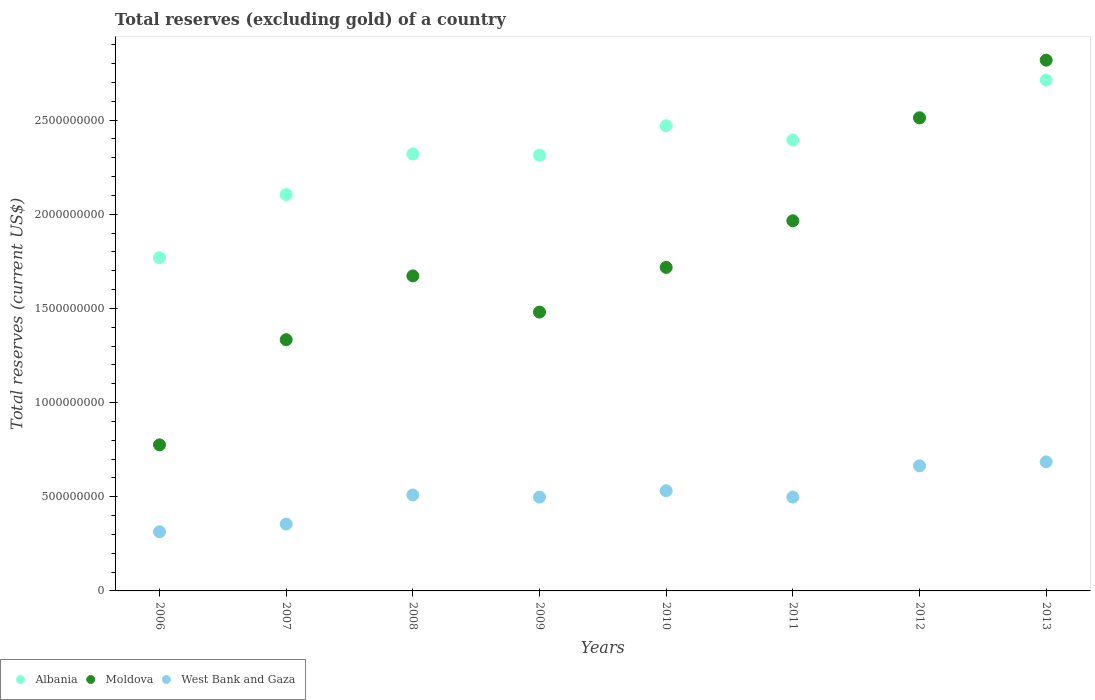What is the total reserves (excluding gold) in Albania in 2008?
Provide a short and direct response. 2.32e+09. Across all years, what is the maximum total reserves (excluding gold) in Moldova?
Give a very brief answer. 2.82e+09. Across all years, what is the minimum total reserves (excluding gold) in West Bank and Gaza?
Provide a succinct answer. 3.14e+08. In which year was the total reserves (excluding gold) in Moldova minimum?
Provide a succinct answer. 2006. What is the total total reserves (excluding gold) in Albania in the graph?
Give a very brief answer. 1.86e+1. What is the difference between the total reserves (excluding gold) in West Bank and Gaza in 2007 and that in 2012?
Provide a short and direct response. -3.09e+08. What is the difference between the total reserves (excluding gold) in Albania in 2006 and the total reserves (excluding gold) in West Bank and Gaza in 2007?
Your answer should be very brief. 1.41e+09. What is the average total reserves (excluding gold) in Moldova per year?
Give a very brief answer. 1.78e+09. In the year 2013, what is the difference between the total reserves (excluding gold) in Albania and total reserves (excluding gold) in Moldova?
Keep it short and to the point. -1.05e+08. What is the ratio of the total reserves (excluding gold) in Albania in 2010 to that in 2013?
Your answer should be compact. 0.91. What is the difference between the highest and the second highest total reserves (excluding gold) in West Bank and Gaza?
Keep it short and to the point. 2.12e+07. What is the difference between the highest and the lowest total reserves (excluding gold) in Albania?
Keep it short and to the point. 9.44e+08. In how many years, is the total reserves (excluding gold) in Moldova greater than the average total reserves (excluding gold) in Moldova taken over all years?
Keep it short and to the point. 3. Is it the case that in every year, the sum of the total reserves (excluding gold) in Moldova and total reserves (excluding gold) in West Bank and Gaza  is greater than the total reserves (excluding gold) in Albania?
Your answer should be compact. No. Does the total reserves (excluding gold) in West Bank and Gaza monotonically increase over the years?
Your response must be concise. No. Is the total reserves (excluding gold) in Moldova strictly greater than the total reserves (excluding gold) in Albania over the years?
Keep it short and to the point. No. How many dotlines are there?
Provide a succinct answer. 3. How many years are there in the graph?
Offer a terse response. 8. What is the difference between two consecutive major ticks on the Y-axis?
Give a very brief answer. 5.00e+08. Are the values on the major ticks of Y-axis written in scientific E-notation?
Offer a terse response. No. Does the graph contain any zero values?
Your response must be concise. No. Where does the legend appear in the graph?
Offer a very short reply. Bottom left. How are the legend labels stacked?
Provide a succinct answer. Horizontal. What is the title of the graph?
Provide a succinct answer. Total reserves (excluding gold) of a country. What is the label or title of the Y-axis?
Ensure brevity in your answer.  Total reserves (current US$). What is the Total reserves (current US$) of Albania in 2006?
Give a very brief answer. 1.77e+09. What is the Total reserves (current US$) of Moldova in 2006?
Provide a succinct answer. 7.75e+08. What is the Total reserves (current US$) in West Bank and Gaza in 2006?
Provide a succinct answer. 3.14e+08. What is the Total reserves (current US$) in Albania in 2007?
Your answer should be very brief. 2.10e+09. What is the Total reserves (current US$) of Moldova in 2007?
Your answer should be very brief. 1.33e+09. What is the Total reserves (current US$) in West Bank and Gaza in 2007?
Provide a short and direct response. 3.55e+08. What is the Total reserves (current US$) in Albania in 2008?
Offer a very short reply. 2.32e+09. What is the Total reserves (current US$) of Moldova in 2008?
Give a very brief answer. 1.67e+09. What is the Total reserves (current US$) of West Bank and Gaza in 2008?
Keep it short and to the point. 5.10e+08. What is the Total reserves (current US$) of Albania in 2009?
Your answer should be compact. 2.31e+09. What is the Total reserves (current US$) of Moldova in 2009?
Give a very brief answer. 1.48e+09. What is the Total reserves (current US$) in West Bank and Gaza in 2009?
Your answer should be compact. 4.98e+08. What is the Total reserves (current US$) of Albania in 2010?
Ensure brevity in your answer.  2.47e+09. What is the Total reserves (current US$) in Moldova in 2010?
Your answer should be compact. 1.72e+09. What is the Total reserves (current US$) in West Bank and Gaza in 2010?
Ensure brevity in your answer.  5.32e+08. What is the Total reserves (current US$) in Albania in 2011?
Keep it short and to the point. 2.39e+09. What is the Total reserves (current US$) in Moldova in 2011?
Make the answer very short. 1.96e+09. What is the Total reserves (current US$) of West Bank and Gaza in 2011?
Ensure brevity in your answer.  4.98e+08. What is the Total reserves (current US$) of Albania in 2012?
Your answer should be very brief. 2.52e+09. What is the Total reserves (current US$) of Moldova in 2012?
Keep it short and to the point. 2.51e+09. What is the Total reserves (current US$) of West Bank and Gaza in 2012?
Offer a terse response. 6.64e+08. What is the Total reserves (current US$) of Albania in 2013?
Provide a succinct answer. 2.71e+09. What is the Total reserves (current US$) in Moldova in 2013?
Your answer should be very brief. 2.82e+09. What is the Total reserves (current US$) in West Bank and Gaza in 2013?
Offer a very short reply. 6.85e+08. Across all years, what is the maximum Total reserves (current US$) of Albania?
Your answer should be compact. 2.71e+09. Across all years, what is the maximum Total reserves (current US$) of Moldova?
Offer a very short reply. 2.82e+09. Across all years, what is the maximum Total reserves (current US$) of West Bank and Gaza?
Your answer should be very brief. 6.85e+08. Across all years, what is the minimum Total reserves (current US$) of Albania?
Keep it short and to the point. 1.77e+09. Across all years, what is the minimum Total reserves (current US$) in Moldova?
Your answer should be very brief. 7.75e+08. Across all years, what is the minimum Total reserves (current US$) of West Bank and Gaza?
Provide a succinct answer. 3.14e+08. What is the total Total reserves (current US$) of Albania in the graph?
Provide a succinct answer. 1.86e+1. What is the total Total reserves (current US$) in Moldova in the graph?
Give a very brief answer. 1.43e+1. What is the total Total reserves (current US$) in West Bank and Gaza in the graph?
Provide a short and direct response. 4.06e+09. What is the difference between the Total reserves (current US$) in Albania in 2006 and that in 2007?
Provide a succinct answer. -3.35e+08. What is the difference between the Total reserves (current US$) of Moldova in 2006 and that in 2007?
Provide a succinct answer. -5.58e+08. What is the difference between the Total reserves (current US$) of West Bank and Gaza in 2006 and that in 2007?
Give a very brief answer. -4.07e+07. What is the difference between the Total reserves (current US$) of Albania in 2006 and that in 2008?
Keep it short and to the point. -5.51e+08. What is the difference between the Total reserves (current US$) of Moldova in 2006 and that in 2008?
Offer a very short reply. -8.97e+08. What is the difference between the Total reserves (current US$) in West Bank and Gaza in 2006 and that in 2008?
Your answer should be compact. -1.95e+08. What is the difference between the Total reserves (current US$) of Albania in 2006 and that in 2009?
Give a very brief answer. -5.45e+08. What is the difference between the Total reserves (current US$) in Moldova in 2006 and that in 2009?
Your answer should be compact. -7.05e+08. What is the difference between the Total reserves (current US$) in West Bank and Gaza in 2006 and that in 2009?
Keep it short and to the point. -1.84e+08. What is the difference between the Total reserves (current US$) in Albania in 2006 and that in 2010?
Give a very brief answer. -7.01e+08. What is the difference between the Total reserves (current US$) in Moldova in 2006 and that in 2010?
Offer a terse response. -9.42e+08. What is the difference between the Total reserves (current US$) of West Bank and Gaza in 2006 and that in 2010?
Offer a very short reply. -2.18e+08. What is the difference between the Total reserves (current US$) in Albania in 2006 and that in 2011?
Your answer should be compact. -6.25e+08. What is the difference between the Total reserves (current US$) in Moldova in 2006 and that in 2011?
Keep it short and to the point. -1.19e+09. What is the difference between the Total reserves (current US$) in West Bank and Gaza in 2006 and that in 2011?
Make the answer very short. -1.84e+08. What is the difference between the Total reserves (current US$) of Albania in 2006 and that in 2012?
Offer a terse response. -7.47e+08. What is the difference between the Total reserves (current US$) in Moldova in 2006 and that in 2012?
Ensure brevity in your answer.  -1.74e+09. What is the difference between the Total reserves (current US$) of West Bank and Gaza in 2006 and that in 2012?
Make the answer very short. -3.50e+08. What is the difference between the Total reserves (current US$) of Albania in 2006 and that in 2013?
Provide a succinct answer. -9.44e+08. What is the difference between the Total reserves (current US$) in Moldova in 2006 and that in 2013?
Offer a terse response. -2.04e+09. What is the difference between the Total reserves (current US$) of West Bank and Gaza in 2006 and that in 2013?
Keep it short and to the point. -3.71e+08. What is the difference between the Total reserves (current US$) in Albania in 2007 and that in 2008?
Keep it short and to the point. -2.16e+08. What is the difference between the Total reserves (current US$) of Moldova in 2007 and that in 2008?
Your answer should be very brief. -3.39e+08. What is the difference between the Total reserves (current US$) of West Bank and Gaza in 2007 and that in 2008?
Your answer should be very brief. -1.55e+08. What is the difference between the Total reserves (current US$) in Albania in 2007 and that in 2009?
Offer a terse response. -2.10e+08. What is the difference between the Total reserves (current US$) of Moldova in 2007 and that in 2009?
Your response must be concise. -1.47e+08. What is the difference between the Total reserves (current US$) in West Bank and Gaza in 2007 and that in 2009?
Your answer should be very brief. -1.43e+08. What is the difference between the Total reserves (current US$) in Albania in 2007 and that in 2010?
Give a very brief answer. -3.65e+08. What is the difference between the Total reserves (current US$) of Moldova in 2007 and that in 2010?
Provide a succinct answer. -3.84e+08. What is the difference between the Total reserves (current US$) of West Bank and Gaza in 2007 and that in 2010?
Keep it short and to the point. -1.77e+08. What is the difference between the Total reserves (current US$) of Albania in 2007 and that in 2011?
Your answer should be compact. -2.90e+08. What is the difference between the Total reserves (current US$) in Moldova in 2007 and that in 2011?
Offer a very short reply. -6.31e+08. What is the difference between the Total reserves (current US$) in West Bank and Gaza in 2007 and that in 2011?
Your answer should be compact. -1.43e+08. What is the difference between the Total reserves (current US$) of Albania in 2007 and that in 2012?
Your answer should be very brief. -4.11e+08. What is the difference between the Total reserves (current US$) of Moldova in 2007 and that in 2012?
Your response must be concise. -1.18e+09. What is the difference between the Total reserves (current US$) of West Bank and Gaza in 2007 and that in 2012?
Offer a terse response. -3.09e+08. What is the difference between the Total reserves (current US$) in Albania in 2007 and that in 2013?
Make the answer very short. -6.08e+08. What is the difference between the Total reserves (current US$) of Moldova in 2007 and that in 2013?
Your response must be concise. -1.48e+09. What is the difference between the Total reserves (current US$) in West Bank and Gaza in 2007 and that in 2013?
Give a very brief answer. -3.30e+08. What is the difference between the Total reserves (current US$) of Albania in 2008 and that in 2009?
Provide a succinct answer. 5.87e+06. What is the difference between the Total reserves (current US$) of Moldova in 2008 and that in 2009?
Provide a succinct answer. 1.92e+08. What is the difference between the Total reserves (current US$) in West Bank and Gaza in 2008 and that in 2009?
Make the answer very short. 1.14e+07. What is the difference between the Total reserves (current US$) in Albania in 2008 and that in 2010?
Provide a short and direct response. -1.50e+08. What is the difference between the Total reserves (current US$) of Moldova in 2008 and that in 2010?
Your answer should be compact. -4.53e+07. What is the difference between the Total reserves (current US$) of West Bank and Gaza in 2008 and that in 2010?
Your answer should be very brief. -2.22e+07. What is the difference between the Total reserves (current US$) in Albania in 2008 and that in 2011?
Provide a succinct answer. -7.41e+07. What is the difference between the Total reserves (current US$) in Moldova in 2008 and that in 2011?
Provide a succinct answer. -2.93e+08. What is the difference between the Total reserves (current US$) in West Bank and Gaza in 2008 and that in 2011?
Ensure brevity in your answer.  1.15e+07. What is the difference between the Total reserves (current US$) of Albania in 2008 and that in 2012?
Offer a very short reply. -1.96e+08. What is the difference between the Total reserves (current US$) in Moldova in 2008 and that in 2012?
Provide a short and direct response. -8.39e+08. What is the difference between the Total reserves (current US$) of West Bank and Gaza in 2008 and that in 2012?
Your response must be concise. -1.55e+08. What is the difference between the Total reserves (current US$) of Albania in 2008 and that in 2013?
Ensure brevity in your answer.  -3.93e+08. What is the difference between the Total reserves (current US$) of Moldova in 2008 and that in 2013?
Make the answer very short. -1.15e+09. What is the difference between the Total reserves (current US$) of West Bank and Gaza in 2008 and that in 2013?
Your response must be concise. -1.76e+08. What is the difference between the Total reserves (current US$) of Albania in 2009 and that in 2010?
Your answer should be compact. -1.56e+08. What is the difference between the Total reserves (current US$) in Moldova in 2009 and that in 2010?
Your answer should be compact. -2.37e+08. What is the difference between the Total reserves (current US$) of West Bank and Gaza in 2009 and that in 2010?
Give a very brief answer. -3.36e+07. What is the difference between the Total reserves (current US$) in Albania in 2009 and that in 2011?
Give a very brief answer. -8.00e+07. What is the difference between the Total reserves (current US$) in Moldova in 2009 and that in 2011?
Your answer should be compact. -4.85e+08. What is the difference between the Total reserves (current US$) of West Bank and Gaza in 2009 and that in 2011?
Provide a succinct answer. 1.26e+05. What is the difference between the Total reserves (current US$) in Albania in 2009 and that in 2012?
Your response must be concise. -2.02e+08. What is the difference between the Total reserves (current US$) of Moldova in 2009 and that in 2012?
Your answer should be very brief. -1.03e+09. What is the difference between the Total reserves (current US$) of West Bank and Gaza in 2009 and that in 2012?
Your answer should be compact. -1.66e+08. What is the difference between the Total reserves (current US$) of Albania in 2009 and that in 2013?
Your answer should be compact. -3.98e+08. What is the difference between the Total reserves (current US$) in Moldova in 2009 and that in 2013?
Your answer should be compact. -1.34e+09. What is the difference between the Total reserves (current US$) of West Bank and Gaza in 2009 and that in 2013?
Make the answer very short. -1.87e+08. What is the difference between the Total reserves (current US$) of Albania in 2010 and that in 2011?
Make the answer very short. 7.56e+07. What is the difference between the Total reserves (current US$) of Moldova in 2010 and that in 2011?
Offer a terse response. -2.47e+08. What is the difference between the Total reserves (current US$) in West Bank and Gaza in 2010 and that in 2011?
Offer a terse response. 3.37e+07. What is the difference between the Total reserves (current US$) in Albania in 2010 and that in 2012?
Provide a short and direct response. -4.61e+07. What is the difference between the Total reserves (current US$) of Moldova in 2010 and that in 2012?
Keep it short and to the point. -7.93e+08. What is the difference between the Total reserves (current US$) in West Bank and Gaza in 2010 and that in 2012?
Your answer should be very brief. -1.32e+08. What is the difference between the Total reserves (current US$) of Albania in 2010 and that in 2013?
Keep it short and to the point. -2.43e+08. What is the difference between the Total reserves (current US$) of Moldova in 2010 and that in 2013?
Your response must be concise. -1.10e+09. What is the difference between the Total reserves (current US$) of West Bank and Gaza in 2010 and that in 2013?
Offer a terse response. -1.53e+08. What is the difference between the Total reserves (current US$) in Albania in 2011 and that in 2012?
Provide a short and direct response. -1.22e+08. What is the difference between the Total reserves (current US$) of Moldova in 2011 and that in 2012?
Offer a very short reply. -5.46e+08. What is the difference between the Total reserves (current US$) of West Bank and Gaza in 2011 and that in 2012?
Keep it short and to the point. -1.66e+08. What is the difference between the Total reserves (current US$) of Albania in 2011 and that in 2013?
Provide a succinct answer. -3.18e+08. What is the difference between the Total reserves (current US$) in Moldova in 2011 and that in 2013?
Provide a succinct answer. -8.53e+08. What is the difference between the Total reserves (current US$) in West Bank and Gaza in 2011 and that in 2013?
Give a very brief answer. -1.87e+08. What is the difference between the Total reserves (current US$) in Albania in 2012 and that in 2013?
Give a very brief answer. -1.97e+08. What is the difference between the Total reserves (current US$) in Moldova in 2012 and that in 2013?
Keep it short and to the point. -3.07e+08. What is the difference between the Total reserves (current US$) in West Bank and Gaza in 2012 and that in 2013?
Offer a terse response. -2.12e+07. What is the difference between the Total reserves (current US$) in Albania in 2006 and the Total reserves (current US$) in Moldova in 2007?
Provide a short and direct response. 4.35e+08. What is the difference between the Total reserves (current US$) in Albania in 2006 and the Total reserves (current US$) in West Bank and Gaza in 2007?
Your response must be concise. 1.41e+09. What is the difference between the Total reserves (current US$) in Moldova in 2006 and the Total reserves (current US$) in West Bank and Gaza in 2007?
Your answer should be very brief. 4.21e+08. What is the difference between the Total reserves (current US$) of Albania in 2006 and the Total reserves (current US$) of Moldova in 2008?
Your answer should be very brief. 9.64e+07. What is the difference between the Total reserves (current US$) in Albania in 2006 and the Total reserves (current US$) in West Bank and Gaza in 2008?
Provide a short and direct response. 1.26e+09. What is the difference between the Total reserves (current US$) in Moldova in 2006 and the Total reserves (current US$) in West Bank and Gaza in 2008?
Your answer should be very brief. 2.66e+08. What is the difference between the Total reserves (current US$) in Albania in 2006 and the Total reserves (current US$) in Moldova in 2009?
Your answer should be very brief. 2.89e+08. What is the difference between the Total reserves (current US$) in Albania in 2006 and the Total reserves (current US$) in West Bank and Gaza in 2009?
Provide a succinct answer. 1.27e+09. What is the difference between the Total reserves (current US$) in Moldova in 2006 and the Total reserves (current US$) in West Bank and Gaza in 2009?
Provide a short and direct response. 2.77e+08. What is the difference between the Total reserves (current US$) in Albania in 2006 and the Total reserves (current US$) in Moldova in 2010?
Provide a short and direct response. 5.11e+07. What is the difference between the Total reserves (current US$) in Albania in 2006 and the Total reserves (current US$) in West Bank and Gaza in 2010?
Give a very brief answer. 1.24e+09. What is the difference between the Total reserves (current US$) in Moldova in 2006 and the Total reserves (current US$) in West Bank and Gaza in 2010?
Your response must be concise. 2.44e+08. What is the difference between the Total reserves (current US$) of Albania in 2006 and the Total reserves (current US$) of Moldova in 2011?
Provide a succinct answer. -1.96e+08. What is the difference between the Total reserves (current US$) in Albania in 2006 and the Total reserves (current US$) in West Bank and Gaza in 2011?
Provide a short and direct response. 1.27e+09. What is the difference between the Total reserves (current US$) in Moldova in 2006 and the Total reserves (current US$) in West Bank and Gaza in 2011?
Your answer should be very brief. 2.77e+08. What is the difference between the Total reserves (current US$) of Albania in 2006 and the Total reserves (current US$) of Moldova in 2012?
Offer a very short reply. -7.42e+08. What is the difference between the Total reserves (current US$) of Albania in 2006 and the Total reserves (current US$) of West Bank and Gaza in 2012?
Provide a short and direct response. 1.10e+09. What is the difference between the Total reserves (current US$) in Moldova in 2006 and the Total reserves (current US$) in West Bank and Gaza in 2012?
Make the answer very short. 1.11e+08. What is the difference between the Total reserves (current US$) in Albania in 2006 and the Total reserves (current US$) in Moldova in 2013?
Provide a short and direct response. -1.05e+09. What is the difference between the Total reserves (current US$) of Albania in 2006 and the Total reserves (current US$) of West Bank and Gaza in 2013?
Ensure brevity in your answer.  1.08e+09. What is the difference between the Total reserves (current US$) of Moldova in 2006 and the Total reserves (current US$) of West Bank and Gaza in 2013?
Your answer should be very brief. 9.03e+07. What is the difference between the Total reserves (current US$) of Albania in 2007 and the Total reserves (current US$) of Moldova in 2008?
Your response must be concise. 4.32e+08. What is the difference between the Total reserves (current US$) of Albania in 2007 and the Total reserves (current US$) of West Bank and Gaza in 2008?
Keep it short and to the point. 1.59e+09. What is the difference between the Total reserves (current US$) in Moldova in 2007 and the Total reserves (current US$) in West Bank and Gaza in 2008?
Provide a short and direct response. 8.24e+08. What is the difference between the Total reserves (current US$) of Albania in 2007 and the Total reserves (current US$) of Moldova in 2009?
Keep it short and to the point. 6.24e+08. What is the difference between the Total reserves (current US$) of Albania in 2007 and the Total reserves (current US$) of West Bank and Gaza in 2009?
Ensure brevity in your answer.  1.61e+09. What is the difference between the Total reserves (current US$) of Moldova in 2007 and the Total reserves (current US$) of West Bank and Gaza in 2009?
Offer a terse response. 8.36e+08. What is the difference between the Total reserves (current US$) in Albania in 2007 and the Total reserves (current US$) in Moldova in 2010?
Give a very brief answer. 3.87e+08. What is the difference between the Total reserves (current US$) in Albania in 2007 and the Total reserves (current US$) in West Bank and Gaza in 2010?
Your response must be concise. 1.57e+09. What is the difference between the Total reserves (current US$) of Moldova in 2007 and the Total reserves (current US$) of West Bank and Gaza in 2010?
Offer a very short reply. 8.02e+08. What is the difference between the Total reserves (current US$) of Albania in 2007 and the Total reserves (current US$) of Moldova in 2011?
Provide a short and direct response. 1.39e+08. What is the difference between the Total reserves (current US$) in Albania in 2007 and the Total reserves (current US$) in West Bank and Gaza in 2011?
Offer a terse response. 1.61e+09. What is the difference between the Total reserves (current US$) in Moldova in 2007 and the Total reserves (current US$) in West Bank and Gaza in 2011?
Offer a terse response. 8.36e+08. What is the difference between the Total reserves (current US$) in Albania in 2007 and the Total reserves (current US$) in Moldova in 2012?
Make the answer very short. -4.07e+08. What is the difference between the Total reserves (current US$) in Albania in 2007 and the Total reserves (current US$) in West Bank and Gaza in 2012?
Provide a short and direct response. 1.44e+09. What is the difference between the Total reserves (current US$) of Moldova in 2007 and the Total reserves (current US$) of West Bank and Gaza in 2012?
Your answer should be very brief. 6.70e+08. What is the difference between the Total reserves (current US$) in Albania in 2007 and the Total reserves (current US$) in Moldova in 2013?
Ensure brevity in your answer.  -7.14e+08. What is the difference between the Total reserves (current US$) in Albania in 2007 and the Total reserves (current US$) in West Bank and Gaza in 2013?
Give a very brief answer. 1.42e+09. What is the difference between the Total reserves (current US$) in Moldova in 2007 and the Total reserves (current US$) in West Bank and Gaza in 2013?
Make the answer very short. 6.48e+08. What is the difference between the Total reserves (current US$) in Albania in 2008 and the Total reserves (current US$) in Moldova in 2009?
Keep it short and to the point. 8.40e+08. What is the difference between the Total reserves (current US$) in Albania in 2008 and the Total reserves (current US$) in West Bank and Gaza in 2009?
Offer a terse response. 1.82e+09. What is the difference between the Total reserves (current US$) in Moldova in 2008 and the Total reserves (current US$) in West Bank and Gaza in 2009?
Your answer should be compact. 1.17e+09. What is the difference between the Total reserves (current US$) of Albania in 2008 and the Total reserves (current US$) of Moldova in 2010?
Provide a succinct answer. 6.02e+08. What is the difference between the Total reserves (current US$) in Albania in 2008 and the Total reserves (current US$) in West Bank and Gaza in 2010?
Provide a succinct answer. 1.79e+09. What is the difference between the Total reserves (current US$) of Moldova in 2008 and the Total reserves (current US$) of West Bank and Gaza in 2010?
Your answer should be very brief. 1.14e+09. What is the difference between the Total reserves (current US$) in Albania in 2008 and the Total reserves (current US$) in Moldova in 2011?
Offer a very short reply. 3.55e+08. What is the difference between the Total reserves (current US$) in Albania in 2008 and the Total reserves (current US$) in West Bank and Gaza in 2011?
Ensure brevity in your answer.  1.82e+09. What is the difference between the Total reserves (current US$) of Moldova in 2008 and the Total reserves (current US$) of West Bank and Gaza in 2011?
Ensure brevity in your answer.  1.17e+09. What is the difference between the Total reserves (current US$) of Albania in 2008 and the Total reserves (current US$) of Moldova in 2012?
Offer a very short reply. -1.91e+08. What is the difference between the Total reserves (current US$) in Albania in 2008 and the Total reserves (current US$) in West Bank and Gaza in 2012?
Provide a succinct answer. 1.66e+09. What is the difference between the Total reserves (current US$) of Moldova in 2008 and the Total reserves (current US$) of West Bank and Gaza in 2012?
Your answer should be compact. 1.01e+09. What is the difference between the Total reserves (current US$) of Albania in 2008 and the Total reserves (current US$) of Moldova in 2013?
Ensure brevity in your answer.  -4.98e+08. What is the difference between the Total reserves (current US$) of Albania in 2008 and the Total reserves (current US$) of West Bank and Gaza in 2013?
Your answer should be very brief. 1.63e+09. What is the difference between the Total reserves (current US$) in Moldova in 2008 and the Total reserves (current US$) in West Bank and Gaza in 2013?
Provide a short and direct response. 9.87e+08. What is the difference between the Total reserves (current US$) of Albania in 2009 and the Total reserves (current US$) of Moldova in 2010?
Offer a terse response. 5.96e+08. What is the difference between the Total reserves (current US$) in Albania in 2009 and the Total reserves (current US$) in West Bank and Gaza in 2010?
Provide a short and direct response. 1.78e+09. What is the difference between the Total reserves (current US$) in Moldova in 2009 and the Total reserves (current US$) in West Bank and Gaza in 2010?
Ensure brevity in your answer.  9.49e+08. What is the difference between the Total reserves (current US$) of Albania in 2009 and the Total reserves (current US$) of Moldova in 2011?
Offer a terse response. 3.49e+08. What is the difference between the Total reserves (current US$) in Albania in 2009 and the Total reserves (current US$) in West Bank and Gaza in 2011?
Keep it short and to the point. 1.82e+09. What is the difference between the Total reserves (current US$) of Moldova in 2009 and the Total reserves (current US$) of West Bank and Gaza in 2011?
Offer a terse response. 9.82e+08. What is the difference between the Total reserves (current US$) in Albania in 2009 and the Total reserves (current US$) in Moldova in 2012?
Your answer should be compact. -1.97e+08. What is the difference between the Total reserves (current US$) in Albania in 2009 and the Total reserves (current US$) in West Bank and Gaza in 2012?
Your answer should be very brief. 1.65e+09. What is the difference between the Total reserves (current US$) in Moldova in 2009 and the Total reserves (current US$) in West Bank and Gaza in 2012?
Offer a terse response. 8.16e+08. What is the difference between the Total reserves (current US$) of Albania in 2009 and the Total reserves (current US$) of Moldova in 2013?
Your answer should be very brief. -5.04e+08. What is the difference between the Total reserves (current US$) of Albania in 2009 and the Total reserves (current US$) of West Bank and Gaza in 2013?
Your response must be concise. 1.63e+09. What is the difference between the Total reserves (current US$) in Moldova in 2009 and the Total reserves (current US$) in West Bank and Gaza in 2013?
Offer a terse response. 7.95e+08. What is the difference between the Total reserves (current US$) in Albania in 2010 and the Total reserves (current US$) in Moldova in 2011?
Ensure brevity in your answer.  5.05e+08. What is the difference between the Total reserves (current US$) of Albania in 2010 and the Total reserves (current US$) of West Bank and Gaza in 2011?
Offer a very short reply. 1.97e+09. What is the difference between the Total reserves (current US$) in Moldova in 2010 and the Total reserves (current US$) in West Bank and Gaza in 2011?
Offer a very short reply. 1.22e+09. What is the difference between the Total reserves (current US$) in Albania in 2010 and the Total reserves (current US$) in Moldova in 2012?
Your answer should be very brief. -4.15e+07. What is the difference between the Total reserves (current US$) of Albania in 2010 and the Total reserves (current US$) of West Bank and Gaza in 2012?
Offer a very short reply. 1.81e+09. What is the difference between the Total reserves (current US$) of Moldova in 2010 and the Total reserves (current US$) of West Bank and Gaza in 2012?
Give a very brief answer. 1.05e+09. What is the difference between the Total reserves (current US$) of Albania in 2010 and the Total reserves (current US$) of Moldova in 2013?
Offer a very short reply. -3.48e+08. What is the difference between the Total reserves (current US$) of Albania in 2010 and the Total reserves (current US$) of West Bank and Gaza in 2013?
Make the answer very short. 1.78e+09. What is the difference between the Total reserves (current US$) in Moldova in 2010 and the Total reserves (current US$) in West Bank and Gaza in 2013?
Make the answer very short. 1.03e+09. What is the difference between the Total reserves (current US$) of Albania in 2011 and the Total reserves (current US$) of Moldova in 2012?
Keep it short and to the point. -1.17e+08. What is the difference between the Total reserves (current US$) in Albania in 2011 and the Total reserves (current US$) in West Bank and Gaza in 2012?
Ensure brevity in your answer.  1.73e+09. What is the difference between the Total reserves (current US$) of Moldova in 2011 and the Total reserves (current US$) of West Bank and Gaza in 2012?
Keep it short and to the point. 1.30e+09. What is the difference between the Total reserves (current US$) of Albania in 2011 and the Total reserves (current US$) of Moldova in 2013?
Ensure brevity in your answer.  -4.24e+08. What is the difference between the Total reserves (current US$) in Albania in 2011 and the Total reserves (current US$) in West Bank and Gaza in 2013?
Offer a very short reply. 1.71e+09. What is the difference between the Total reserves (current US$) in Moldova in 2011 and the Total reserves (current US$) in West Bank and Gaza in 2013?
Your answer should be compact. 1.28e+09. What is the difference between the Total reserves (current US$) in Albania in 2012 and the Total reserves (current US$) in Moldova in 2013?
Provide a short and direct response. -3.02e+08. What is the difference between the Total reserves (current US$) in Albania in 2012 and the Total reserves (current US$) in West Bank and Gaza in 2013?
Your answer should be very brief. 1.83e+09. What is the difference between the Total reserves (current US$) of Moldova in 2012 and the Total reserves (current US$) of West Bank and Gaza in 2013?
Provide a succinct answer. 1.83e+09. What is the average Total reserves (current US$) of Albania per year?
Your answer should be very brief. 2.32e+09. What is the average Total reserves (current US$) of Moldova per year?
Offer a very short reply. 1.78e+09. What is the average Total reserves (current US$) of West Bank and Gaza per year?
Your answer should be compact. 5.07e+08. In the year 2006, what is the difference between the Total reserves (current US$) in Albania and Total reserves (current US$) in Moldova?
Offer a very short reply. 9.93e+08. In the year 2006, what is the difference between the Total reserves (current US$) of Albania and Total reserves (current US$) of West Bank and Gaza?
Offer a very short reply. 1.45e+09. In the year 2006, what is the difference between the Total reserves (current US$) in Moldova and Total reserves (current US$) in West Bank and Gaza?
Make the answer very short. 4.61e+08. In the year 2007, what is the difference between the Total reserves (current US$) in Albania and Total reserves (current US$) in Moldova?
Offer a terse response. 7.71e+08. In the year 2007, what is the difference between the Total reserves (current US$) of Albania and Total reserves (current US$) of West Bank and Gaza?
Ensure brevity in your answer.  1.75e+09. In the year 2007, what is the difference between the Total reserves (current US$) of Moldova and Total reserves (current US$) of West Bank and Gaza?
Offer a very short reply. 9.79e+08. In the year 2008, what is the difference between the Total reserves (current US$) of Albania and Total reserves (current US$) of Moldova?
Your answer should be compact. 6.47e+08. In the year 2008, what is the difference between the Total reserves (current US$) in Albania and Total reserves (current US$) in West Bank and Gaza?
Make the answer very short. 1.81e+09. In the year 2008, what is the difference between the Total reserves (current US$) of Moldova and Total reserves (current US$) of West Bank and Gaza?
Keep it short and to the point. 1.16e+09. In the year 2009, what is the difference between the Total reserves (current US$) in Albania and Total reserves (current US$) in Moldova?
Offer a very short reply. 8.34e+08. In the year 2009, what is the difference between the Total reserves (current US$) of Albania and Total reserves (current US$) of West Bank and Gaza?
Ensure brevity in your answer.  1.82e+09. In the year 2009, what is the difference between the Total reserves (current US$) in Moldova and Total reserves (current US$) in West Bank and Gaza?
Make the answer very short. 9.82e+08. In the year 2010, what is the difference between the Total reserves (current US$) in Albania and Total reserves (current US$) in Moldova?
Offer a very short reply. 7.52e+08. In the year 2010, what is the difference between the Total reserves (current US$) of Albania and Total reserves (current US$) of West Bank and Gaza?
Keep it short and to the point. 1.94e+09. In the year 2010, what is the difference between the Total reserves (current US$) in Moldova and Total reserves (current US$) in West Bank and Gaza?
Offer a very short reply. 1.19e+09. In the year 2011, what is the difference between the Total reserves (current US$) of Albania and Total reserves (current US$) of Moldova?
Your answer should be very brief. 4.29e+08. In the year 2011, what is the difference between the Total reserves (current US$) in Albania and Total reserves (current US$) in West Bank and Gaza?
Your answer should be compact. 1.90e+09. In the year 2011, what is the difference between the Total reserves (current US$) in Moldova and Total reserves (current US$) in West Bank and Gaza?
Provide a short and direct response. 1.47e+09. In the year 2012, what is the difference between the Total reserves (current US$) in Albania and Total reserves (current US$) in Moldova?
Offer a very short reply. 4.60e+06. In the year 2012, what is the difference between the Total reserves (current US$) in Albania and Total reserves (current US$) in West Bank and Gaza?
Keep it short and to the point. 1.85e+09. In the year 2012, what is the difference between the Total reserves (current US$) in Moldova and Total reserves (current US$) in West Bank and Gaza?
Keep it short and to the point. 1.85e+09. In the year 2013, what is the difference between the Total reserves (current US$) of Albania and Total reserves (current US$) of Moldova?
Give a very brief answer. -1.05e+08. In the year 2013, what is the difference between the Total reserves (current US$) of Albania and Total reserves (current US$) of West Bank and Gaza?
Provide a short and direct response. 2.03e+09. In the year 2013, what is the difference between the Total reserves (current US$) of Moldova and Total reserves (current US$) of West Bank and Gaza?
Provide a succinct answer. 2.13e+09. What is the ratio of the Total reserves (current US$) of Albania in 2006 to that in 2007?
Provide a short and direct response. 0.84. What is the ratio of the Total reserves (current US$) of Moldova in 2006 to that in 2007?
Make the answer very short. 0.58. What is the ratio of the Total reserves (current US$) of West Bank and Gaza in 2006 to that in 2007?
Your answer should be very brief. 0.89. What is the ratio of the Total reserves (current US$) in Albania in 2006 to that in 2008?
Make the answer very short. 0.76. What is the ratio of the Total reserves (current US$) in Moldova in 2006 to that in 2008?
Ensure brevity in your answer.  0.46. What is the ratio of the Total reserves (current US$) of West Bank and Gaza in 2006 to that in 2008?
Offer a very short reply. 0.62. What is the ratio of the Total reserves (current US$) of Albania in 2006 to that in 2009?
Make the answer very short. 0.76. What is the ratio of the Total reserves (current US$) in Moldova in 2006 to that in 2009?
Your response must be concise. 0.52. What is the ratio of the Total reserves (current US$) in West Bank and Gaza in 2006 to that in 2009?
Keep it short and to the point. 0.63. What is the ratio of the Total reserves (current US$) of Albania in 2006 to that in 2010?
Your answer should be very brief. 0.72. What is the ratio of the Total reserves (current US$) in Moldova in 2006 to that in 2010?
Your answer should be very brief. 0.45. What is the ratio of the Total reserves (current US$) of West Bank and Gaza in 2006 to that in 2010?
Keep it short and to the point. 0.59. What is the ratio of the Total reserves (current US$) of Albania in 2006 to that in 2011?
Keep it short and to the point. 0.74. What is the ratio of the Total reserves (current US$) in Moldova in 2006 to that in 2011?
Offer a very short reply. 0.39. What is the ratio of the Total reserves (current US$) in West Bank and Gaza in 2006 to that in 2011?
Provide a succinct answer. 0.63. What is the ratio of the Total reserves (current US$) in Albania in 2006 to that in 2012?
Provide a succinct answer. 0.7. What is the ratio of the Total reserves (current US$) of Moldova in 2006 to that in 2012?
Keep it short and to the point. 0.31. What is the ratio of the Total reserves (current US$) of West Bank and Gaza in 2006 to that in 2012?
Offer a very short reply. 0.47. What is the ratio of the Total reserves (current US$) in Albania in 2006 to that in 2013?
Ensure brevity in your answer.  0.65. What is the ratio of the Total reserves (current US$) in Moldova in 2006 to that in 2013?
Ensure brevity in your answer.  0.28. What is the ratio of the Total reserves (current US$) in West Bank and Gaza in 2006 to that in 2013?
Make the answer very short. 0.46. What is the ratio of the Total reserves (current US$) in Albania in 2007 to that in 2008?
Provide a short and direct response. 0.91. What is the ratio of the Total reserves (current US$) of Moldova in 2007 to that in 2008?
Your answer should be very brief. 0.8. What is the ratio of the Total reserves (current US$) of West Bank and Gaza in 2007 to that in 2008?
Make the answer very short. 0.7. What is the ratio of the Total reserves (current US$) of Albania in 2007 to that in 2009?
Give a very brief answer. 0.91. What is the ratio of the Total reserves (current US$) in Moldova in 2007 to that in 2009?
Your answer should be very brief. 0.9. What is the ratio of the Total reserves (current US$) in West Bank and Gaza in 2007 to that in 2009?
Your answer should be very brief. 0.71. What is the ratio of the Total reserves (current US$) of Albania in 2007 to that in 2010?
Offer a terse response. 0.85. What is the ratio of the Total reserves (current US$) in Moldova in 2007 to that in 2010?
Your answer should be very brief. 0.78. What is the ratio of the Total reserves (current US$) of West Bank and Gaza in 2007 to that in 2010?
Your response must be concise. 0.67. What is the ratio of the Total reserves (current US$) in Albania in 2007 to that in 2011?
Your response must be concise. 0.88. What is the ratio of the Total reserves (current US$) of Moldova in 2007 to that in 2011?
Ensure brevity in your answer.  0.68. What is the ratio of the Total reserves (current US$) of West Bank and Gaza in 2007 to that in 2011?
Offer a very short reply. 0.71. What is the ratio of the Total reserves (current US$) in Albania in 2007 to that in 2012?
Give a very brief answer. 0.84. What is the ratio of the Total reserves (current US$) of Moldova in 2007 to that in 2012?
Offer a very short reply. 0.53. What is the ratio of the Total reserves (current US$) in West Bank and Gaza in 2007 to that in 2012?
Offer a very short reply. 0.53. What is the ratio of the Total reserves (current US$) of Albania in 2007 to that in 2013?
Provide a short and direct response. 0.78. What is the ratio of the Total reserves (current US$) in Moldova in 2007 to that in 2013?
Provide a succinct answer. 0.47. What is the ratio of the Total reserves (current US$) of West Bank and Gaza in 2007 to that in 2013?
Give a very brief answer. 0.52. What is the ratio of the Total reserves (current US$) in Albania in 2008 to that in 2009?
Offer a very short reply. 1. What is the ratio of the Total reserves (current US$) of Moldova in 2008 to that in 2009?
Keep it short and to the point. 1.13. What is the ratio of the Total reserves (current US$) of West Bank and Gaza in 2008 to that in 2009?
Your answer should be very brief. 1.02. What is the ratio of the Total reserves (current US$) in Albania in 2008 to that in 2010?
Your answer should be compact. 0.94. What is the ratio of the Total reserves (current US$) of Moldova in 2008 to that in 2010?
Provide a succinct answer. 0.97. What is the ratio of the Total reserves (current US$) in West Bank and Gaza in 2008 to that in 2010?
Give a very brief answer. 0.96. What is the ratio of the Total reserves (current US$) of Moldova in 2008 to that in 2011?
Offer a very short reply. 0.85. What is the ratio of the Total reserves (current US$) in West Bank and Gaza in 2008 to that in 2011?
Give a very brief answer. 1.02. What is the ratio of the Total reserves (current US$) in Albania in 2008 to that in 2012?
Keep it short and to the point. 0.92. What is the ratio of the Total reserves (current US$) in Moldova in 2008 to that in 2012?
Make the answer very short. 0.67. What is the ratio of the Total reserves (current US$) in West Bank and Gaza in 2008 to that in 2012?
Keep it short and to the point. 0.77. What is the ratio of the Total reserves (current US$) in Albania in 2008 to that in 2013?
Your answer should be very brief. 0.86. What is the ratio of the Total reserves (current US$) of Moldova in 2008 to that in 2013?
Provide a short and direct response. 0.59. What is the ratio of the Total reserves (current US$) of West Bank and Gaza in 2008 to that in 2013?
Provide a short and direct response. 0.74. What is the ratio of the Total reserves (current US$) in Albania in 2009 to that in 2010?
Offer a very short reply. 0.94. What is the ratio of the Total reserves (current US$) in Moldova in 2009 to that in 2010?
Provide a short and direct response. 0.86. What is the ratio of the Total reserves (current US$) of West Bank and Gaza in 2009 to that in 2010?
Provide a succinct answer. 0.94. What is the ratio of the Total reserves (current US$) of Albania in 2009 to that in 2011?
Give a very brief answer. 0.97. What is the ratio of the Total reserves (current US$) in Moldova in 2009 to that in 2011?
Offer a terse response. 0.75. What is the ratio of the Total reserves (current US$) in Albania in 2009 to that in 2012?
Keep it short and to the point. 0.92. What is the ratio of the Total reserves (current US$) in Moldova in 2009 to that in 2012?
Make the answer very short. 0.59. What is the ratio of the Total reserves (current US$) of West Bank and Gaza in 2009 to that in 2012?
Provide a succinct answer. 0.75. What is the ratio of the Total reserves (current US$) in Albania in 2009 to that in 2013?
Your answer should be compact. 0.85. What is the ratio of the Total reserves (current US$) of Moldova in 2009 to that in 2013?
Offer a terse response. 0.53. What is the ratio of the Total reserves (current US$) in West Bank and Gaza in 2009 to that in 2013?
Keep it short and to the point. 0.73. What is the ratio of the Total reserves (current US$) of Albania in 2010 to that in 2011?
Give a very brief answer. 1.03. What is the ratio of the Total reserves (current US$) of Moldova in 2010 to that in 2011?
Give a very brief answer. 0.87. What is the ratio of the Total reserves (current US$) of West Bank and Gaza in 2010 to that in 2011?
Your response must be concise. 1.07. What is the ratio of the Total reserves (current US$) in Albania in 2010 to that in 2012?
Provide a short and direct response. 0.98. What is the ratio of the Total reserves (current US$) of Moldova in 2010 to that in 2012?
Keep it short and to the point. 0.68. What is the ratio of the Total reserves (current US$) of West Bank and Gaza in 2010 to that in 2012?
Provide a succinct answer. 0.8. What is the ratio of the Total reserves (current US$) of Albania in 2010 to that in 2013?
Your response must be concise. 0.91. What is the ratio of the Total reserves (current US$) of Moldova in 2010 to that in 2013?
Ensure brevity in your answer.  0.61. What is the ratio of the Total reserves (current US$) in West Bank and Gaza in 2010 to that in 2013?
Keep it short and to the point. 0.78. What is the ratio of the Total reserves (current US$) of Albania in 2011 to that in 2012?
Ensure brevity in your answer.  0.95. What is the ratio of the Total reserves (current US$) in Moldova in 2011 to that in 2012?
Your answer should be compact. 0.78. What is the ratio of the Total reserves (current US$) in West Bank and Gaza in 2011 to that in 2012?
Make the answer very short. 0.75. What is the ratio of the Total reserves (current US$) of Albania in 2011 to that in 2013?
Give a very brief answer. 0.88. What is the ratio of the Total reserves (current US$) in Moldova in 2011 to that in 2013?
Your answer should be compact. 0.7. What is the ratio of the Total reserves (current US$) of West Bank and Gaza in 2011 to that in 2013?
Your answer should be very brief. 0.73. What is the ratio of the Total reserves (current US$) of Albania in 2012 to that in 2013?
Provide a succinct answer. 0.93. What is the ratio of the Total reserves (current US$) of Moldova in 2012 to that in 2013?
Your response must be concise. 0.89. What is the ratio of the Total reserves (current US$) in West Bank and Gaza in 2012 to that in 2013?
Your answer should be very brief. 0.97. What is the difference between the highest and the second highest Total reserves (current US$) in Albania?
Provide a short and direct response. 1.97e+08. What is the difference between the highest and the second highest Total reserves (current US$) in Moldova?
Provide a succinct answer. 3.07e+08. What is the difference between the highest and the second highest Total reserves (current US$) of West Bank and Gaza?
Provide a succinct answer. 2.12e+07. What is the difference between the highest and the lowest Total reserves (current US$) in Albania?
Offer a very short reply. 9.44e+08. What is the difference between the highest and the lowest Total reserves (current US$) of Moldova?
Give a very brief answer. 2.04e+09. What is the difference between the highest and the lowest Total reserves (current US$) in West Bank and Gaza?
Offer a terse response. 3.71e+08. 